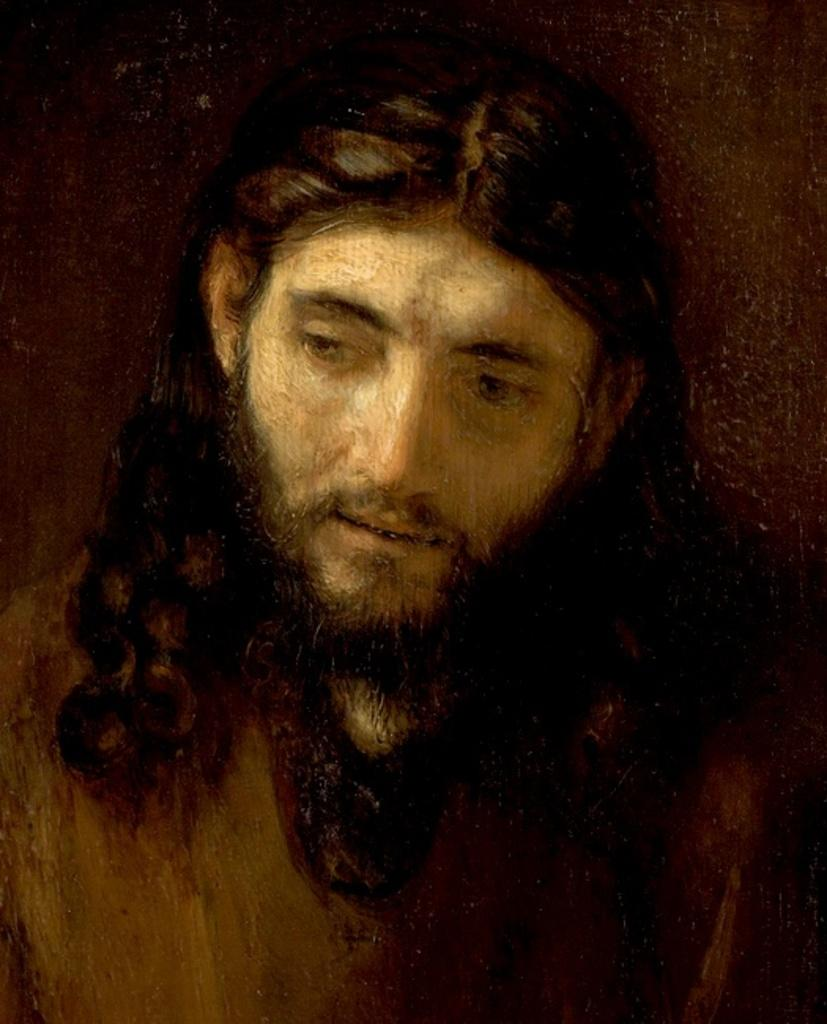What is the main subject of the image? There is a painting in the image. What is depicted in the painting? The painting depicts a person. Can you describe the appearance of the person in the painting? The person in the painting has a beard and long hair. What type of drain is visible in the painting? There is no drain present in the painting; it depicts a person with a beard and long hair. 